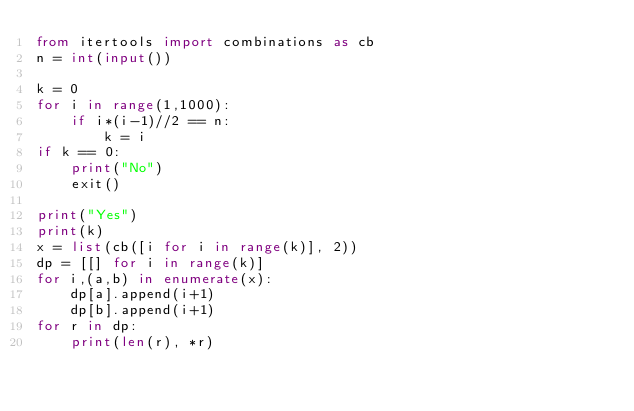Convert code to text. <code><loc_0><loc_0><loc_500><loc_500><_Python_>from itertools import combinations as cb   
n = int(input())

k = 0
for i in range(1,1000):
    if i*(i-1)//2 == n:
        k = i
if k == 0:
    print("No")
    exit()

print("Yes")
print(k)
x = list(cb([i for i in range(k)], 2))
dp = [[] for i in range(k)]
for i,(a,b) in enumerate(x):
    dp[a].append(i+1)
    dp[b].append(i+1)
for r in dp:
    print(len(r), *r)</code> 